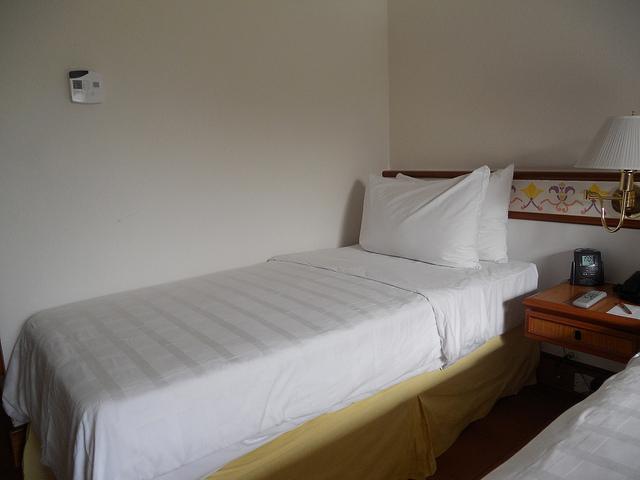What color is the bedspread?
Short answer required. White. How many pillows are on the bed?
Concise answer only. 2. Where is the thermostat?
Give a very brief answer. On wall. How many pillows are there?
Quick response, please. 2. Is there a bed?
Quick response, please. Yes. Is there a lamp on the nightstand?
Give a very brief answer. No. Is there a comforter on the bed?
Answer briefly. No. What pattern is on the blanket?
Be succinct. Stripes. 